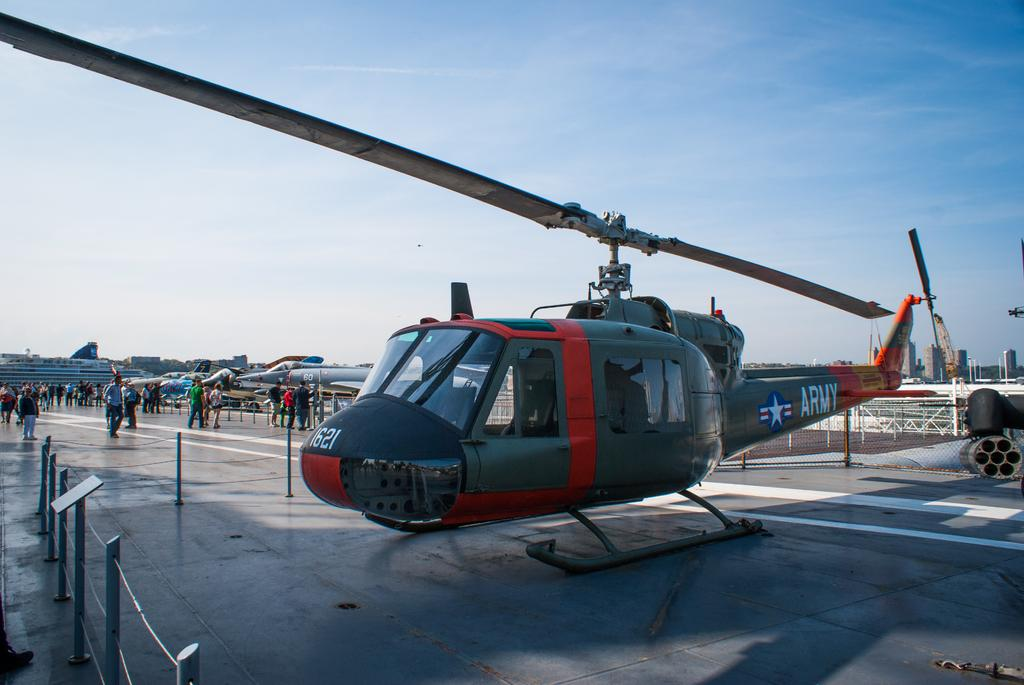What type of vehicle is the main subject in the image? There is a helicopter in the image. Are there any other vehicles in the image? Yes, there are airplanes in the image. What can be seen on the ground in the image? There are people on the ground in the image. What is separating the people from the vehicles? There is a fence in the image. What else is visible in the image besides the vehicles and people? There are objects and buildings in the image. What is visible in the background of the image? The sky is visible in the background of the image, along with the buildings. Can you see a boat in the image? No, there is no boat present in the image. Are the people in the image kissing? There is no indication of people kissing in the image. 